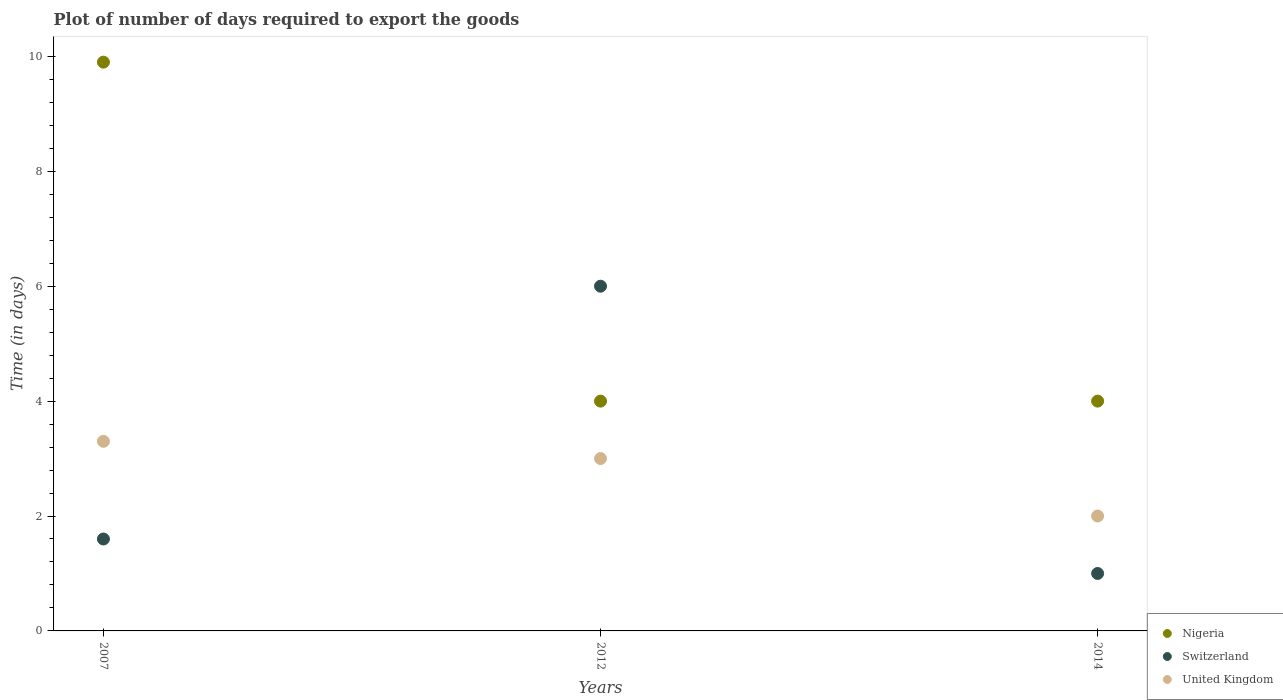In which year was the time required to export goods in United Kingdom maximum?
Your answer should be compact. 2007. What is the total time required to export goods in United Kingdom in the graph?
Make the answer very short. 8.3. What is the difference between the time required to export goods in United Kingdom in 2012 and that in 2014?
Provide a succinct answer. 1. What is the average time required to export goods in United Kingdom per year?
Keep it short and to the point. 2.77. In the year 2014, what is the difference between the time required to export goods in United Kingdom and time required to export goods in Switzerland?
Provide a short and direct response. 1. What is the ratio of the time required to export goods in Nigeria in 2007 to that in 2012?
Your answer should be very brief. 2.48. Is the difference between the time required to export goods in United Kingdom in 2007 and 2012 greater than the difference between the time required to export goods in Switzerland in 2007 and 2012?
Offer a very short reply. Yes. What is the difference between the highest and the second highest time required to export goods in Nigeria?
Offer a very short reply. 5.9. What is the difference between the highest and the lowest time required to export goods in United Kingdom?
Keep it short and to the point. 1.3. Is the sum of the time required to export goods in United Kingdom in 2007 and 2012 greater than the maximum time required to export goods in Switzerland across all years?
Make the answer very short. Yes. Does the time required to export goods in Nigeria monotonically increase over the years?
Ensure brevity in your answer.  No. Is the time required to export goods in United Kingdom strictly greater than the time required to export goods in Switzerland over the years?
Your answer should be compact. No. Is the time required to export goods in Nigeria strictly less than the time required to export goods in Switzerland over the years?
Offer a very short reply. No. What is the difference between two consecutive major ticks on the Y-axis?
Make the answer very short. 2. Are the values on the major ticks of Y-axis written in scientific E-notation?
Keep it short and to the point. No. Does the graph contain any zero values?
Your response must be concise. No. Does the graph contain grids?
Provide a succinct answer. No. How are the legend labels stacked?
Give a very brief answer. Vertical. What is the title of the graph?
Offer a terse response. Plot of number of days required to export the goods. Does "St. Lucia" appear as one of the legend labels in the graph?
Make the answer very short. No. What is the label or title of the X-axis?
Offer a terse response. Years. What is the label or title of the Y-axis?
Provide a succinct answer. Time (in days). What is the Time (in days) of Switzerland in 2007?
Your answer should be compact. 1.6. What is the Time (in days) in United Kingdom in 2007?
Ensure brevity in your answer.  3.3. What is the Time (in days) in Nigeria in 2012?
Give a very brief answer. 4. What is the Time (in days) in Switzerland in 2012?
Your answer should be compact. 6. What is the Time (in days) of United Kingdom in 2012?
Your response must be concise. 3. What is the Time (in days) in Switzerland in 2014?
Give a very brief answer. 1. What is the Time (in days) of United Kingdom in 2014?
Offer a terse response. 2. Across all years, what is the maximum Time (in days) of Nigeria?
Keep it short and to the point. 9.9. Across all years, what is the minimum Time (in days) in Nigeria?
Provide a succinct answer. 4. Across all years, what is the minimum Time (in days) of United Kingdom?
Your answer should be very brief. 2. What is the total Time (in days) of United Kingdom in the graph?
Your response must be concise. 8.3. What is the difference between the Time (in days) of Nigeria in 2007 and that in 2012?
Your response must be concise. 5.9. What is the difference between the Time (in days) of United Kingdom in 2007 and that in 2012?
Provide a succinct answer. 0.3. What is the difference between the Time (in days) in Switzerland in 2007 and that in 2014?
Keep it short and to the point. 0.6. What is the difference between the Time (in days) in United Kingdom in 2007 and that in 2014?
Your response must be concise. 1.3. What is the difference between the Time (in days) in Switzerland in 2012 and that in 2014?
Give a very brief answer. 5. What is the difference between the Time (in days) in Nigeria in 2007 and the Time (in days) in Switzerland in 2012?
Your response must be concise. 3.9. What is the difference between the Time (in days) in Nigeria in 2007 and the Time (in days) in Switzerland in 2014?
Your answer should be compact. 8.9. What is the difference between the Time (in days) in Switzerland in 2007 and the Time (in days) in United Kingdom in 2014?
Ensure brevity in your answer.  -0.4. What is the difference between the Time (in days) of Nigeria in 2012 and the Time (in days) of Switzerland in 2014?
Keep it short and to the point. 3. What is the difference between the Time (in days) of Switzerland in 2012 and the Time (in days) of United Kingdom in 2014?
Offer a very short reply. 4. What is the average Time (in days) of Nigeria per year?
Provide a succinct answer. 5.97. What is the average Time (in days) of Switzerland per year?
Offer a terse response. 2.87. What is the average Time (in days) in United Kingdom per year?
Keep it short and to the point. 2.77. In the year 2007, what is the difference between the Time (in days) of Switzerland and Time (in days) of United Kingdom?
Keep it short and to the point. -1.7. In the year 2012, what is the difference between the Time (in days) of Nigeria and Time (in days) of United Kingdom?
Provide a succinct answer. 1. In the year 2012, what is the difference between the Time (in days) in Switzerland and Time (in days) in United Kingdom?
Your response must be concise. 3. In the year 2014, what is the difference between the Time (in days) in Nigeria and Time (in days) in Switzerland?
Provide a short and direct response. 3. In the year 2014, what is the difference between the Time (in days) of Nigeria and Time (in days) of United Kingdom?
Ensure brevity in your answer.  2. In the year 2014, what is the difference between the Time (in days) in Switzerland and Time (in days) in United Kingdom?
Give a very brief answer. -1. What is the ratio of the Time (in days) of Nigeria in 2007 to that in 2012?
Ensure brevity in your answer.  2.48. What is the ratio of the Time (in days) of Switzerland in 2007 to that in 2012?
Provide a succinct answer. 0.27. What is the ratio of the Time (in days) of United Kingdom in 2007 to that in 2012?
Ensure brevity in your answer.  1.1. What is the ratio of the Time (in days) in Nigeria in 2007 to that in 2014?
Your answer should be compact. 2.48. What is the ratio of the Time (in days) of United Kingdom in 2007 to that in 2014?
Your response must be concise. 1.65. What is the difference between the highest and the second highest Time (in days) in Nigeria?
Provide a succinct answer. 5.9. What is the difference between the highest and the second highest Time (in days) of Switzerland?
Ensure brevity in your answer.  4.4. What is the difference between the highest and the lowest Time (in days) of Switzerland?
Offer a terse response. 5. 